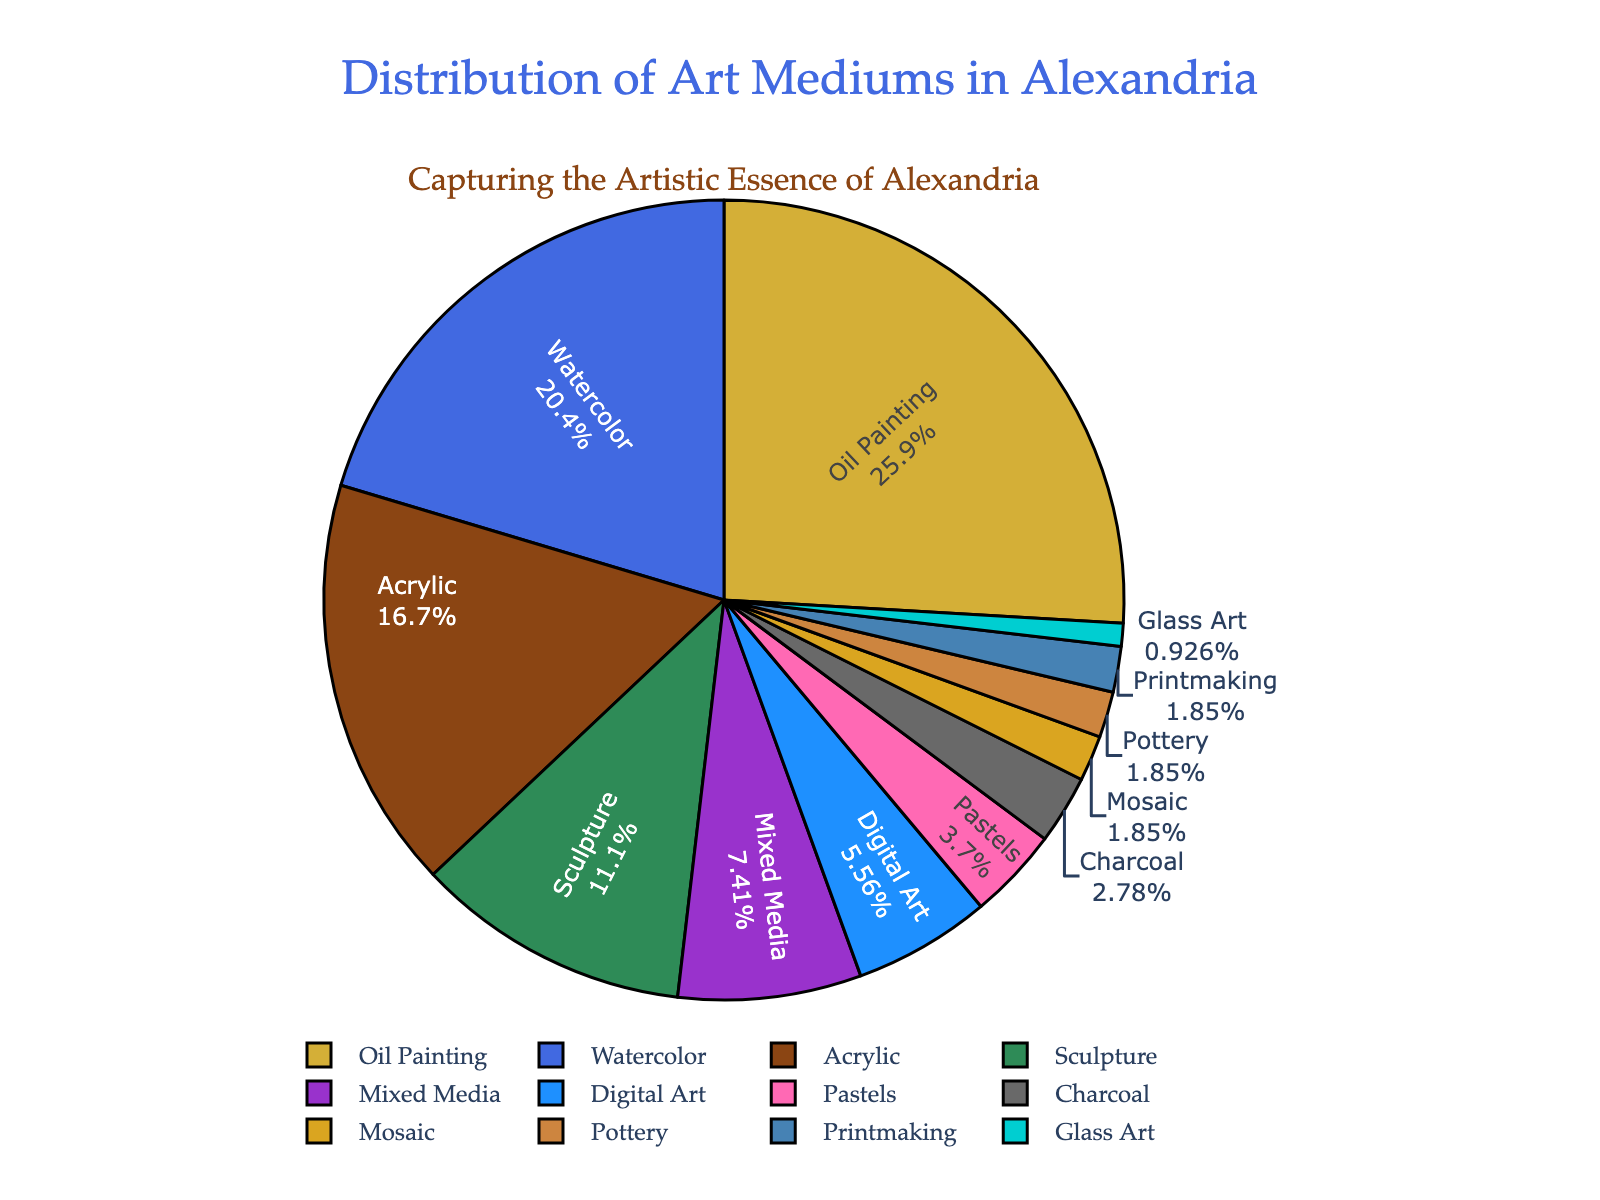Which art medium is the most popular among Alexandria-based artists? By observing the figure, the largest segment of the pie chart represents the most popular art medium. It is labeled as "Oil Painting" with 28%.
Answer: Oil Painting Which art mediums have a lower percentage than Digital Art? Digital Art is marked on the pie chart with 6%. All segments with a percentage less than 6% are compared. They are Pastels (4%), Charcoal (3%), Mosaic (2%), Pottery (2%), Printmaking (2%), and Glass Art (1%).
Answer: Pastels, Charcoal, Mosaic, Pottery, Printmaking, Glass Art What is the total percentage of artists using Oil Painting and Watercolor? The individual percentages for Oil Painting and Watercolor are 28% and 22%, respectively. Summing these gives 28 + 22 = 50.
Answer: 50% How much more popular is Oil Painting compared to Acrylic? The percentage for Oil Painting is 28%, and for Acrylic, it is 18%. The difference is calculated as 28 - 18 = 10.
Answer: 10% Which two mediums together account for exactly 14% of the artists? By observing the figure, Charcoal (3%), Mosaic (2%), Pottery (2%), Printmaking (2%), and Glass Art (1%) have percentages less than or equal to 14%. Only the percentages for Sculpture (12%) and Printmaking (2%) sum to 14%. So, the mediums are Sculpture and Printmaking.
Answer: Sculpture and Printmaking Are there more artists using Watercolor or Acrylic? By how much? From the figure, Watercolor is at 22%, and Acrylic is at 18%. To find the difference: 22 - 18 = 4.
Answer: Watercolor, 4% What fraction of artists use mediums with 2% or less representation? Adding the percentages for Mosaic (2%), Pottery (2%), Printmaking (2%), and Glass Art (1%): 2 + 2 + 2 + 1 = 7%. Converting it to a fraction, 7/100 or simplified, 7/100.
Answer: 7/100 Which medium has the least representation in the pie chart? The smallest segment on the pie chart corresponds to Glass Art with a 1% share.
Answer: Glass Art 